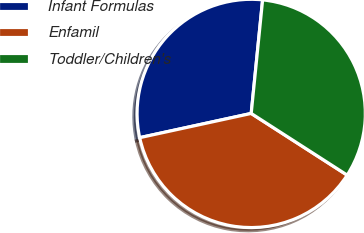Convert chart to OTSL. <chart><loc_0><loc_0><loc_500><loc_500><pie_chart><fcel>Infant Formulas<fcel>Enfamil<fcel>Toddler/Children's<nl><fcel>30.0%<fcel>37.5%<fcel>32.5%<nl></chart> 